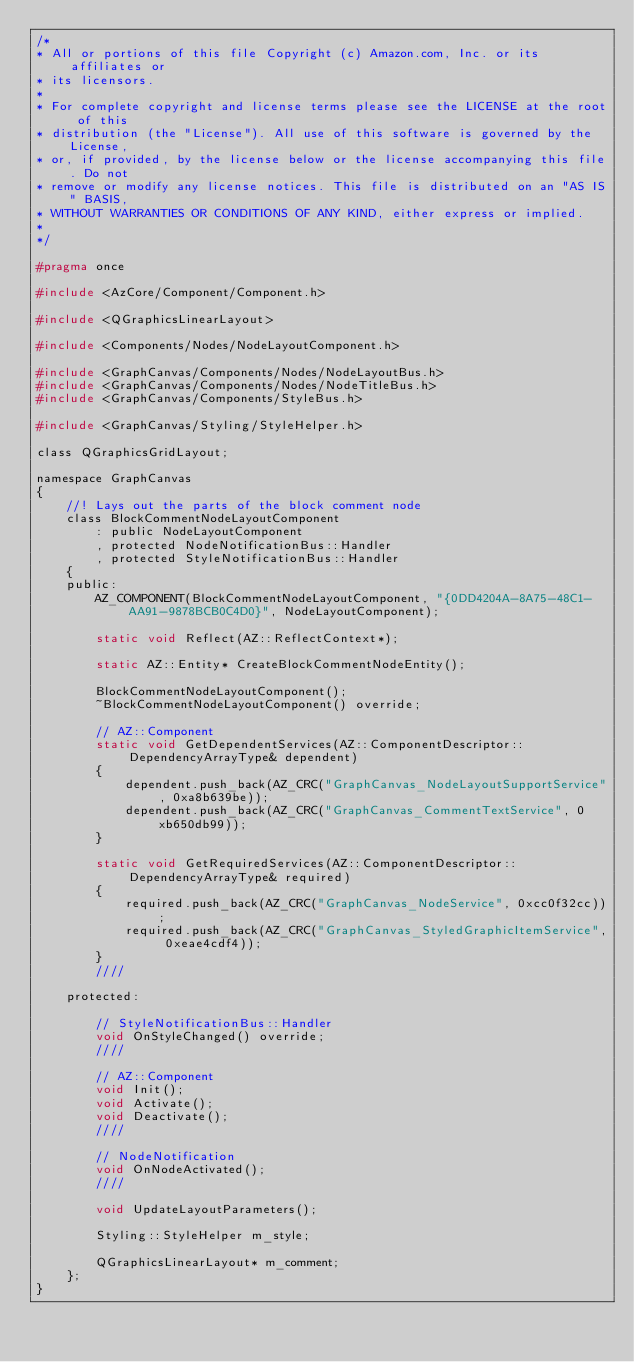<code> <loc_0><loc_0><loc_500><loc_500><_C_>/*
* All or portions of this file Copyright (c) Amazon.com, Inc. or its affiliates or
* its licensors.
*
* For complete copyright and license terms please see the LICENSE at the root of this
* distribution (the "License"). All use of this software is governed by the License,
* or, if provided, by the license below or the license accompanying this file. Do not
* remove or modify any license notices. This file is distributed on an "AS IS" BASIS,
* WITHOUT WARRANTIES OR CONDITIONS OF ANY KIND, either express or implied.
*
*/

#pragma once

#include <AzCore/Component/Component.h>

#include <QGraphicsLinearLayout>

#include <Components/Nodes/NodeLayoutComponent.h>

#include <GraphCanvas/Components/Nodes/NodeLayoutBus.h>
#include <GraphCanvas/Components/Nodes/NodeTitleBus.h>
#include <GraphCanvas/Components/StyleBus.h>

#include <GraphCanvas/Styling/StyleHelper.h>

class QGraphicsGridLayout;

namespace GraphCanvas
{
    //! Lays out the parts of the block comment node
    class BlockCommentNodeLayoutComponent
        : public NodeLayoutComponent
        , protected NodeNotificationBus::Handler
        , protected StyleNotificationBus::Handler
    {
    public:
        AZ_COMPONENT(BlockCommentNodeLayoutComponent, "{0DD4204A-8A75-48C1-AA91-9878BCB0C4D0}", NodeLayoutComponent);

        static void Reflect(AZ::ReflectContext*);

        static AZ::Entity* CreateBlockCommentNodeEntity();

        BlockCommentNodeLayoutComponent();
        ~BlockCommentNodeLayoutComponent() override;

        // AZ::Component
        static void GetDependentServices(AZ::ComponentDescriptor::DependencyArrayType& dependent)
        {
            dependent.push_back(AZ_CRC("GraphCanvas_NodeLayoutSupportService", 0xa8b639be));
            dependent.push_back(AZ_CRC("GraphCanvas_CommentTextService", 0xb650db99));
        }

        static void GetRequiredServices(AZ::ComponentDescriptor::DependencyArrayType& required)
        {
            required.push_back(AZ_CRC("GraphCanvas_NodeService", 0xcc0f32cc));
            required.push_back(AZ_CRC("GraphCanvas_StyledGraphicItemService", 0xeae4cdf4));
        }
        ////

    protected:

        // StyleNotificationBus::Handler
        void OnStyleChanged() override;
        ////

        // AZ::Component
        void Init();
        void Activate();
        void Deactivate();
        ////

        // NodeNotification
        void OnNodeActivated();
        ////

        void UpdateLayoutParameters();

        Styling::StyleHelper m_style;

        QGraphicsLinearLayout* m_comment;
    };
}</code> 